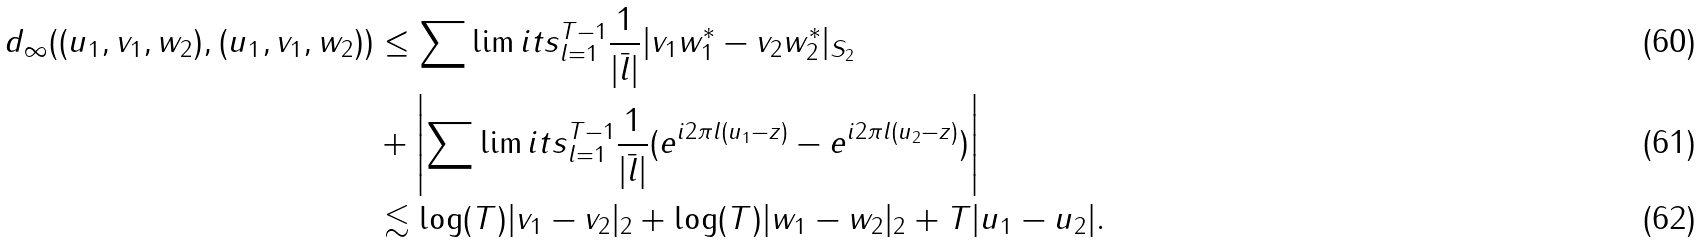Convert formula to latex. <formula><loc_0><loc_0><loc_500><loc_500>d _ { \infty } ( ( u _ { 1 } , v _ { 1 } , w _ { 2 } ) , ( u _ { 1 } , v _ { 1 } , w _ { 2 } ) ) & \leq \sum \lim i t s _ { l = 1 } ^ { T - 1 } \frac { 1 } { | \bar { l } | } | v _ { 1 } w _ { 1 } ^ { * } - v _ { 2 } w _ { 2 } ^ { * } | _ { S _ { 2 } } \\ & + \left | \sum \lim i t s _ { l = 1 } ^ { T - 1 } \frac { 1 } { | \bar { l } | } ( e ^ { i 2 \pi l ( u _ { 1 } - z ) } - e ^ { i 2 \pi l ( u _ { 2 } - z ) } ) \right | \\ & \lesssim \log ( T ) | v _ { 1 } - v _ { 2 } | _ { 2 } + \log ( T ) | w _ { 1 } - w _ { 2 } | _ { 2 } + T | u _ { 1 } - u _ { 2 } | .</formula> 